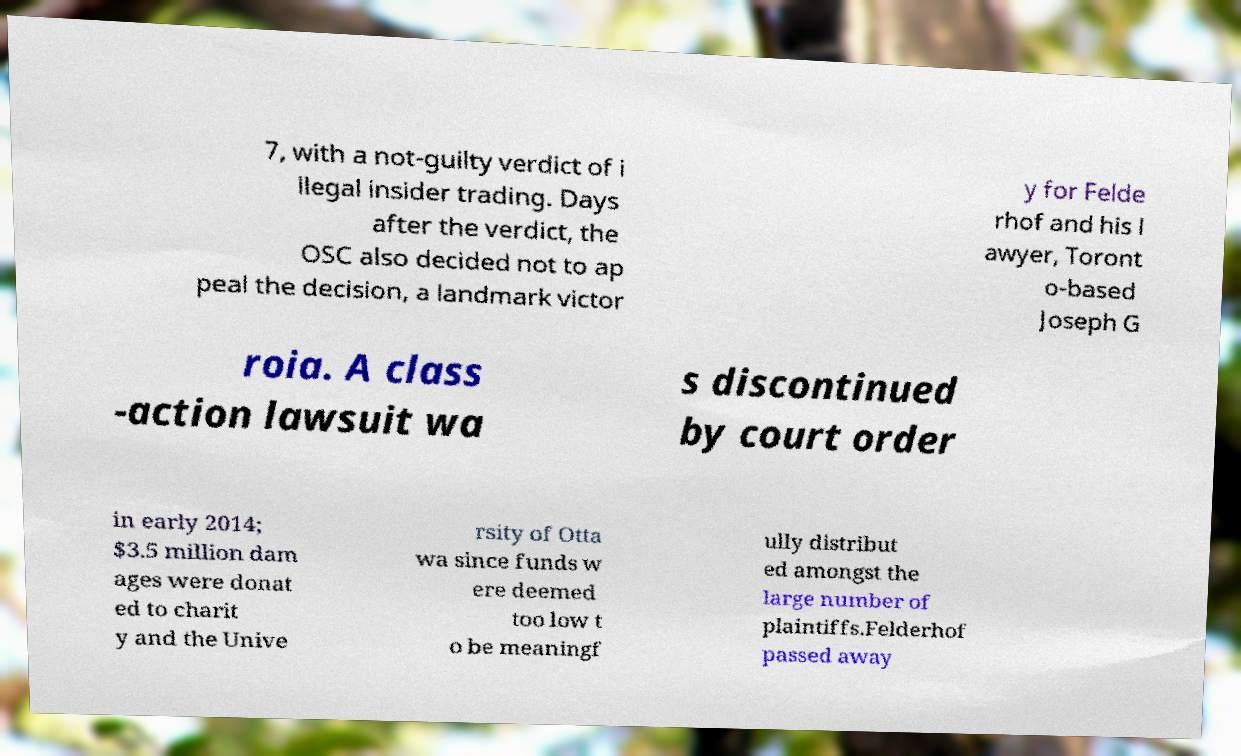Could you extract and type out the text from this image? 7, with a not-guilty verdict of i llegal insider trading. Days after the verdict, the OSC also decided not to ap peal the decision, a landmark victor y for Felde rhof and his l awyer, Toront o-based Joseph G roia. A class -action lawsuit wa s discontinued by court order in early 2014; $3.5 million dam ages were donat ed to charit y and the Unive rsity of Otta wa since funds w ere deemed too low t o be meaningf ully distribut ed amongst the large number of plaintiffs.Felderhof passed away 